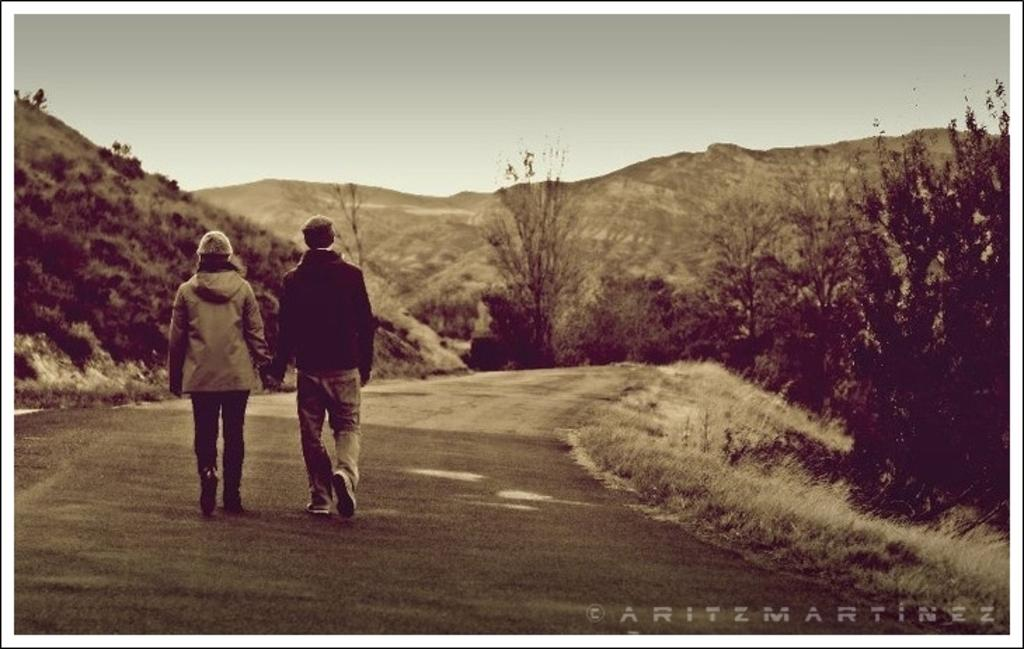What is the color scheme of the image? The image is black and white. Who or what can be seen in the image? There are people and trees in the image. What other natural elements are present in the image? There are plants and hills in the image. What is the ground like in the image? The ground is visible with some grass. Is there any text in the image? Yes, there is text in the bottom right corner of the image. How many babies are present in the image? There are no babies present in the image. What type of book is being read by the minister in the image? There is no minister or book present in the image. 